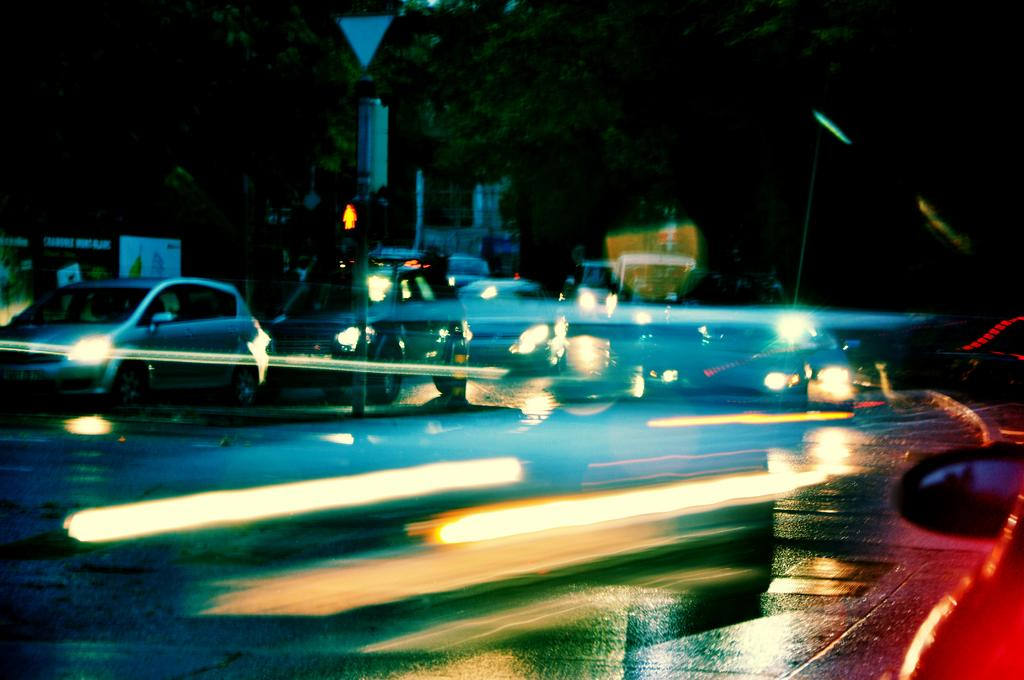What can be seen on the road in the image? There are vehicles on the road in the image. What structures are present in the image? There are poles and a traffic signal in the image. What type of signs or notices are visible in the image? There are boards in the image. What can be seen in the background of the image? Trees and objects are visible in the background of the image. What type of pancake is being used to move the vehicles in the image? There is no pancake present in the image, and vehicles are not being moved by any pancake. 